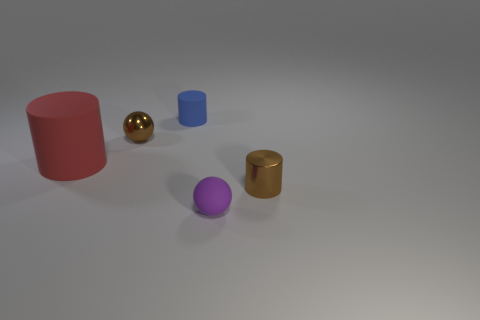Are there any large yellow cylinders? The image shows various geometric shapes, but there are no large yellow cylinders. The only cylinder present is small and gold in color, positioned toward the right side of the image. 